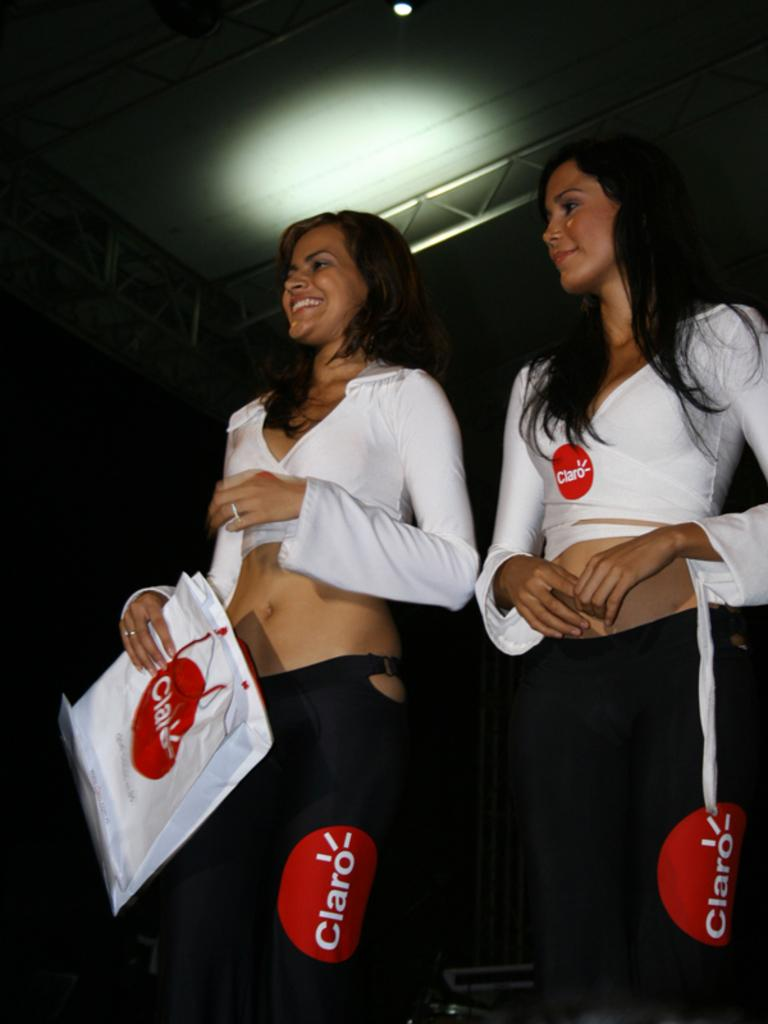<image>
Summarize the visual content of the image. Two women wearing black pants and white shirts display the logo for Claro 